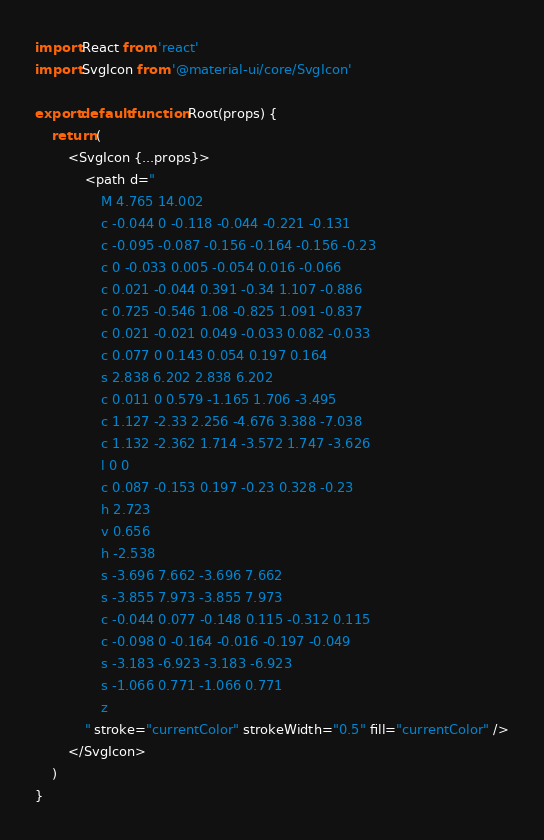<code> <loc_0><loc_0><loc_500><loc_500><_JavaScript_>import React from 'react'
import SvgIcon from '@material-ui/core/SvgIcon'

export default function Root(props) {
	return (
		<SvgIcon {...props}>
			<path d="
				M 4.765 14.002
				c -0.044 0 -0.118 -0.044 -0.221 -0.131
				c -0.095 -0.087 -0.156 -0.164 -0.156 -0.23
				c 0 -0.033 0.005 -0.054 0.016 -0.066
				c 0.021 -0.044 0.391 -0.34 1.107 -0.886
				c 0.725 -0.546 1.08 -0.825 1.091 -0.837
				c 0.021 -0.021 0.049 -0.033 0.082 -0.033
				c 0.077 0 0.143 0.054 0.197 0.164
				s 2.838 6.202 2.838 6.202
				c 0.011 0 0.579 -1.165 1.706 -3.495
				c 1.127 -2.33 2.256 -4.676 3.388 -7.038
				c 1.132 -2.362 1.714 -3.572 1.747 -3.626
				l 0 0
				c 0.087 -0.153 0.197 -0.23 0.328 -0.23
				h 2.723
				v 0.656
				h -2.538
				s -3.696 7.662 -3.696 7.662
				s -3.855 7.973 -3.855 7.973
				c -0.044 0.077 -0.148 0.115 -0.312 0.115
				c -0.098 0 -0.164 -0.016 -0.197 -0.049
				s -3.183 -6.923 -3.183 -6.923
				s -1.066 0.771 -1.066 0.771
				z
			" stroke="currentColor" strokeWidth="0.5" fill="currentColor" />
		</SvgIcon>
	)
}

</code> 